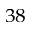<formula> <loc_0><loc_0><loc_500><loc_500>^ { 3 8 }</formula> 